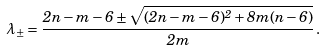Convert formula to latex. <formula><loc_0><loc_0><loc_500><loc_500>\lambda _ { \pm } = \frac { 2 n - m - 6 \pm \sqrt { ( 2 n - m - 6 ) ^ { 2 } + 8 m ( n - 6 ) } } { 2 m } \, .</formula> 